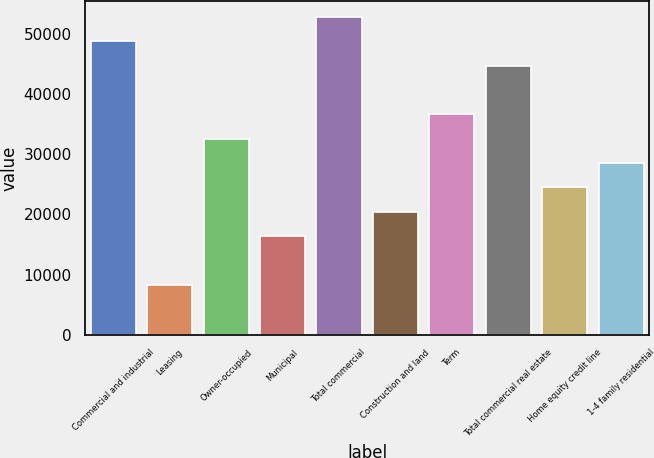Convert chart. <chart><loc_0><loc_0><loc_500><loc_500><bar_chart><fcel>Commercial and industrial<fcel>Leasing<fcel>Owner-occupied<fcel>Municipal<fcel>Total commercial<fcel>Construction and land<fcel>Term<fcel>Total commercial real estate<fcel>Home equity credit line<fcel>1-4 family residential<nl><fcel>48742.6<fcel>8279.6<fcel>32557.4<fcel>16372.2<fcel>52788.9<fcel>20418.5<fcel>36603.7<fcel>44696.3<fcel>24464.8<fcel>28511.1<nl></chart> 